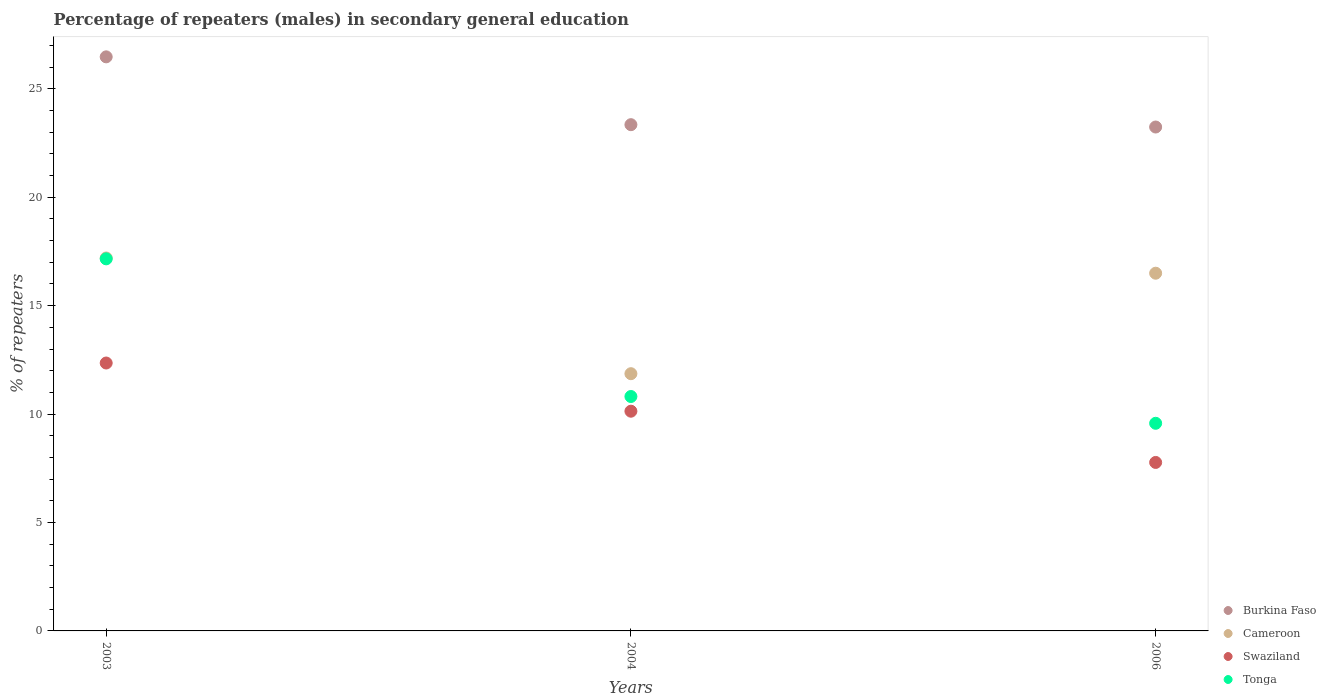How many different coloured dotlines are there?
Provide a short and direct response. 4. Is the number of dotlines equal to the number of legend labels?
Your answer should be very brief. Yes. What is the percentage of male repeaters in Burkina Faso in 2003?
Give a very brief answer. 26.48. Across all years, what is the maximum percentage of male repeaters in Burkina Faso?
Offer a terse response. 26.48. Across all years, what is the minimum percentage of male repeaters in Swaziland?
Your answer should be compact. 7.77. In which year was the percentage of male repeaters in Burkina Faso maximum?
Your response must be concise. 2003. In which year was the percentage of male repeaters in Burkina Faso minimum?
Provide a short and direct response. 2006. What is the total percentage of male repeaters in Burkina Faso in the graph?
Offer a terse response. 73.06. What is the difference between the percentage of male repeaters in Burkina Faso in 2004 and that in 2006?
Make the answer very short. 0.11. What is the difference between the percentage of male repeaters in Tonga in 2006 and the percentage of male repeaters in Cameroon in 2004?
Your response must be concise. -2.29. What is the average percentage of male repeaters in Swaziland per year?
Offer a terse response. 10.09. In the year 2004, what is the difference between the percentage of male repeaters in Tonga and percentage of male repeaters in Swaziland?
Offer a very short reply. 0.68. What is the ratio of the percentage of male repeaters in Cameroon in 2003 to that in 2006?
Your response must be concise. 1.04. Is the percentage of male repeaters in Cameroon in 2003 less than that in 2006?
Your response must be concise. No. Is the difference between the percentage of male repeaters in Tonga in 2003 and 2004 greater than the difference between the percentage of male repeaters in Swaziland in 2003 and 2004?
Your answer should be very brief. Yes. What is the difference between the highest and the second highest percentage of male repeaters in Swaziland?
Provide a succinct answer. 2.22. What is the difference between the highest and the lowest percentage of male repeaters in Burkina Faso?
Give a very brief answer. 3.24. Is it the case that in every year, the sum of the percentage of male repeaters in Swaziland and percentage of male repeaters in Tonga  is greater than the sum of percentage of male repeaters in Cameroon and percentage of male repeaters in Burkina Faso?
Keep it short and to the point. No. Is it the case that in every year, the sum of the percentage of male repeaters in Cameroon and percentage of male repeaters in Swaziland  is greater than the percentage of male repeaters in Tonga?
Your answer should be compact. Yes. How many dotlines are there?
Offer a very short reply. 4. How many years are there in the graph?
Provide a short and direct response. 3. Are the values on the major ticks of Y-axis written in scientific E-notation?
Ensure brevity in your answer.  No. Does the graph contain any zero values?
Offer a terse response. No. Where does the legend appear in the graph?
Your response must be concise. Bottom right. How are the legend labels stacked?
Make the answer very short. Vertical. What is the title of the graph?
Provide a succinct answer. Percentage of repeaters (males) in secondary general education. What is the label or title of the Y-axis?
Your response must be concise. % of repeaters. What is the % of repeaters of Burkina Faso in 2003?
Offer a very short reply. 26.48. What is the % of repeaters in Cameroon in 2003?
Your answer should be compact. 17.2. What is the % of repeaters in Swaziland in 2003?
Your response must be concise. 12.36. What is the % of repeaters of Tonga in 2003?
Offer a terse response. 17.16. What is the % of repeaters in Burkina Faso in 2004?
Provide a short and direct response. 23.35. What is the % of repeaters in Cameroon in 2004?
Provide a succinct answer. 11.86. What is the % of repeaters of Swaziland in 2004?
Keep it short and to the point. 10.13. What is the % of repeaters of Tonga in 2004?
Provide a short and direct response. 10.81. What is the % of repeaters in Burkina Faso in 2006?
Ensure brevity in your answer.  23.24. What is the % of repeaters in Cameroon in 2006?
Offer a very short reply. 16.5. What is the % of repeaters in Swaziland in 2006?
Give a very brief answer. 7.77. What is the % of repeaters of Tonga in 2006?
Your answer should be compact. 9.58. Across all years, what is the maximum % of repeaters in Burkina Faso?
Offer a very short reply. 26.48. Across all years, what is the maximum % of repeaters of Cameroon?
Offer a terse response. 17.2. Across all years, what is the maximum % of repeaters of Swaziland?
Offer a very short reply. 12.36. Across all years, what is the maximum % of repeaters of Tonga?
Your response must be concise. 17.16. Across all years, what is the minimum % of repeaters of Burkina Faso?
Offer a terse response. 23.24. Across all years, what is the minimum % of repeaters in Cameroon?
Your answer should be very brief. 11.86. Across all years, what is the minimum % of repeaters of Swaziland?
Provide a succinct answer. 7.77. Across all years, what is the minimum % of repeaters of Tonga?
Provide a short and direct response. 9.58. What is the total % of repeaters in Burkina Faso in the graph?
Make the answer very short. 73.06. What is the total % of repeaters in Cameroon in the graph?
Keep it short and to the point. 45.56. What is the total % of repeaters of Swaziland in the graph?
Make the answer very short. 30.26. What is the total % of repeaters in Tonga in the graph?
Your answer should be compact. 37.55. What is the difference between the % of repeaters in Burkina Faso in 2003 and that in 2004?
Provide a short and direct response. 3.13. What is the difference between the % of repeaters of Cameroon in 2003 and that in 2004?
Offer a very short reply. 5.34. What is the difference between the % of repeaters of Swaziland in 2003 and that in 2004?
Give a very brief answer. 2.22. What is the difference between the % of repeaters in Tonga in 2003 and that in 2004?
Your answer should be very brief. 6.35. What is the difference between the % of repeaters of Burkina Faso in 2003 and that in 2006?
Give a very brief answer. 3.24. What is the difference between the % of repeaters of Cameroon in 2003 and that in 2006?
Your answer should be compact. 0.7. What is the difference between the % of repeaters of Swaziland in 2003 and that in 2006?
Your response must be concise. 4.59. What is the difference between the % of repeaters in Tonga in 2003 and that in 2006?
Keep it short and to the point. 7.58. What is the difference between the % of repeaters in Burkina Faso in 2004 and that in 2006?
Your answer should be compact. 0.11. What is the difference between the % of repeaters in Cameroon in 2004 and that in 2006?
Your answer should be compact. -4.63. What is the difference between the % of repeaters of Swaziland in 2004 and that in 2006?
Make the answer very short. 2.36. What is the difference between the % of repeaters in Tonga in 2004 and that in 2006?
Offer a very short reply. 1.24. What is the difference between the % of repeaters of Burkina Faso in 2003 and the % of repeaters of Cameroon in 2004?
Your answer should be very brief. 14.61. What is the difference between the % of repeaters of Burkina Faso in 2003 and the % of repeaters of Swaziland in 2004?
Your answer should be very brief. 16.34. What is the difference between the % of repeaters of Burkina Faso in 2003 and the % of repeaters of Tonga in 2004?
Ensure brevity in your answer.  15.66. What is the difference between the % of repeaters in Cameroon in 2003 and the % of repeaters in Swaziland in 2004?
Make the answer very short. 7.07. What is the difference between the % of repeaters in Cameroon in 2003 and the % of repeaters in Tonga in 2004?
Keep it short and to the point. 6.39. What is the difference between the % of repeaters of Swaziland in 2003 and the % of repeaters of Tonga in 2004?
Provide a short and direct response. 1.54. What is the difference between the % of repeaters of Burkina Faso in 2003 and the % of repeaters of Cameroon in 2006?
Ensure brevity in your answer.  9.98. What is the difference between the % of repeaters in Burkina Faso in 2003 and the % of repeaters in Swaziland in 2006?
Your answer should be compact. 18.71. What is the difference between the % of repeaters of Burkina Faso in 2003 and the % of repeaters of Tonga in 2006?
Keep it short and to the point. 16.9. What is the difference between the % of repeaters of Cameroon in 2003 and the % of repeaters of Swaziland in 2006?
Your response must be concise. 9.43. What is the difference between the % of repeaters in Cameroon in 2003 and the % of repeaters in Tonga in 2006?
Your response must be concise. 7.62. What is the difference between the % of repeaters in Swaziland in 2003 and the % of repeaters in Tonga in 2006?
Provide a succinct answer. 2.78. What is the difference between the % of repeaters in Burkina Faso in 2004 and the % of repeaters in Cameroon in 2006?
Your answer should be very brief. 6.85. What is the difference between the % of repeaters of Burkina Faso in 2004 and the % of repeaters of Swaziland in 2006?
Keep it short and to the point. 15.58. What is the difference between the % of repeaters in Burkina Faso in 2004 and the % of repeaters in Tonga in 2006?
Make the answer very short. 13.77. What is the difference between the % of repeaters in Cameroon in 2004 and the % of repeaters in Swaziland in 2006?
Give a very brief answer. 4.09. What is the difference between the % of repeaters in Cameroon in 2004 and the % of repeaters in Tonga in 2006?
Give a very brief answer. 2.29. What is the difference between the % of repeaters in Swaziland in 2004 and the % of repeaters in Tonga in 2006?
Your answer should be compact. 0.56. What is the average % of repeaters in Burkina Faso per year?
Ensure brevity in your answer.  24.35. What is the average % of repeaters in Cameroon per year?
Your response must be concise. 15.19. What is the average % of repeaters of Swaziland per year?
Your answer should be very brief. 10.09. What is the average % of repeaters in Tonga per year?
Offer a terse response. 12.52. In the year 2003, what is the difference between the % of repeaters of Burkina Faso and % of repeaters of Cameroon?
Provide a short and direct response. 9.28. In the year 2003, what is the difference between the % of repeaters in Burkina Faso and % of repeaters in Swaziland?
Your response must be concise. 14.12. In the year 2003, what is the difference between the % of repeaters in Burkina Faso and % of repeaters in Tonga?
Provide a succinct answer. 9.32. In the year 2003, what is the difference between the % of repeaters of Cameroon and % of repeaters of Swaziland?
Your answer should be compact. 4.84. In the year 2003, what is the difference between the % of repeaters in Cameroon and % of repeaters in Tonga?
Ensure brevity in your answer.  0.04. In the year 2003, what is the difference between the % of repeaters in Swaziland and % of repeaters in Tonga?
Your response must be concise. -4.8. In the year 2004, what is the difference between the % of repeaters of Burkina Faso and % of repeaters of Cameroon?
Provide a succinct answer. 11.48. In the year 2004, what is the difference between the % of repeaters of Burkina Faso and % of repeaters of Swaziland?
Offer a terse response. 13.21. In the year 2004, what is the difference between the % of repeaters in Burkina Faso and % of repeaters in Tonga?
Keep it short and to the point. 12.54. In the year 2004, what is the difference between the % of repeaters in Cameroon and % of repeaters in Swaziland?
Offer a terse response. 1.73. In the year 2004, what is the difference between the % of repeaters of Cameroon and % of repeaters of Tonga?
Keep it short and to the point. 1.05. In the year 2004, what is the difference between the % of repeaters in Swaziland and % of repeaters in Tonga?
Provide a short and direct response. -0.68. In the year 2006, what is the difference between the % of repeaters of Burkina Faso and % of repeaters of Cameroon?
Your response must be concise. 6.74. In the year 2006, what is the difference between the % of repeaters of Burkina Faso and % of repeaters of Swaziland?
Offer a terse response. 15.47. In the year 2006, what is the difference between the % of repeaters in Burkina Faso and % of repeaters in Tonga?
Provide a succinct answer. 13.66. In the year 2006, what is the difference between the % of repeaters in Cameroon and % of repeaters in Swaziland?
Offer a very short reply. 8.73. In the year 2006, what is the difference between the % of repeaters of Cameroon and % of repeaters of Tonga?
Provide a short and direct response. 6.92. In the year 2006, what is the difference between the % of repeaters in Swaziland and % of repeaters in Tonga?
Offer a terse response. -1.81. What is the ratio of the % of repeaters of Burkina Faso in 2003 to that in 2004?
Offer a very short reply. 1.13. What is the ratio of the % of repeaters of Cameroon in 2003 to that in 2004?
Your answer should be compact. 1.45. What is the ratio of the % of repeaters in Swaziland in 2003 to that in 2004?
Provide a short and direct response. 1.22. What is the ratio of the % of repeaters in Tonga in 2003 to that in 2004?
Offer a very short reply. 1.59. What is the ratio of the % of repeaters in Burkina Faso in 2003 to that in 2006?
Provide a short and direct response. 1.14. What is the ratio of the % of repeaters in Cameroon in 2003 to that in 2006?
Provide a short and direct response. 1.04. What is the ratio of the % of repeaters in Swaziland in 2003 to that in 2006?
Your answer should be very brief. 1.59. What is the ratio of the % of repeaters in Tonga in 2003 to that in 2006?
Give a very brief answer. 1.79. What is the ratio of the % of repeaters of Cameroon in 2004 to that in 2006?
Your answer should be compact. 0.72. What is the ratio of the % of repeaters in Swaziland in 2004 to that in 2006?
Make the answer very short. 1.3. What is the ratio of the % of repeaters in Tonga in 2004 to that in 2006?
Your answer should be very brief. 1.13. What is the difference between the highest and the second highest % of repeaters of Burkina Faso?
Your answer should be very brief. 3.13. What is the difference between the highest and the second highest % of repeaters in Cameroon?
Your answer should be compact. 0.7. What is the difference between the highest and the second highest % of repeaters in Swaziland?
Ensure brevity in your answer.  2.22. What is the difference between the highest and the second highest % of repeaters in Tonga?
Offer a terse response. 6.35. What is the difference between the highest and the lowest % of repeaters of Burkina Faso?
Make the answer very short. 3.24. What is the difference between the highest and the lowest % of repeaters of Cameroon?
Make the answer very short. 5.34. What is the difference between the highest and the lowest % of repeaters of Swaziland?
Give a very brief answer. 4.59. What is the difference between the highest and the lowest % of repeaters of Tonga?
Offer a very short reply. 7.58. 